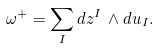<formula> <loc_0><loc_0><loc_500><loc_500>\omega ^ { + } = \sum _ { I } d z ^ { I } \, \wedge d u _ { I } .</formula> 